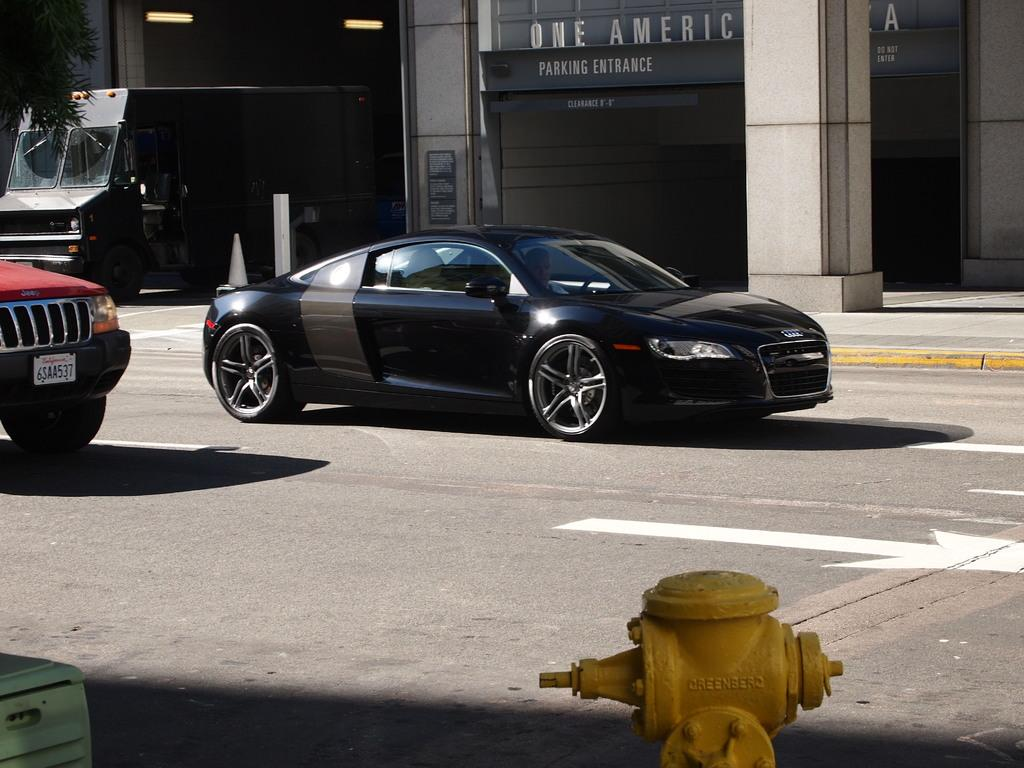What color is the hydrant in the image? The hydrant in the image is yellow. What can be seen on the road in the image? There are objects and vehicles on the road in the image. What is visible in the background of the image? There are buildings, a tree, lights, and a pillar in the background of the image. What type of cheese is being used to build the bridge in the image? There is no bridge or cheese present in the image. 